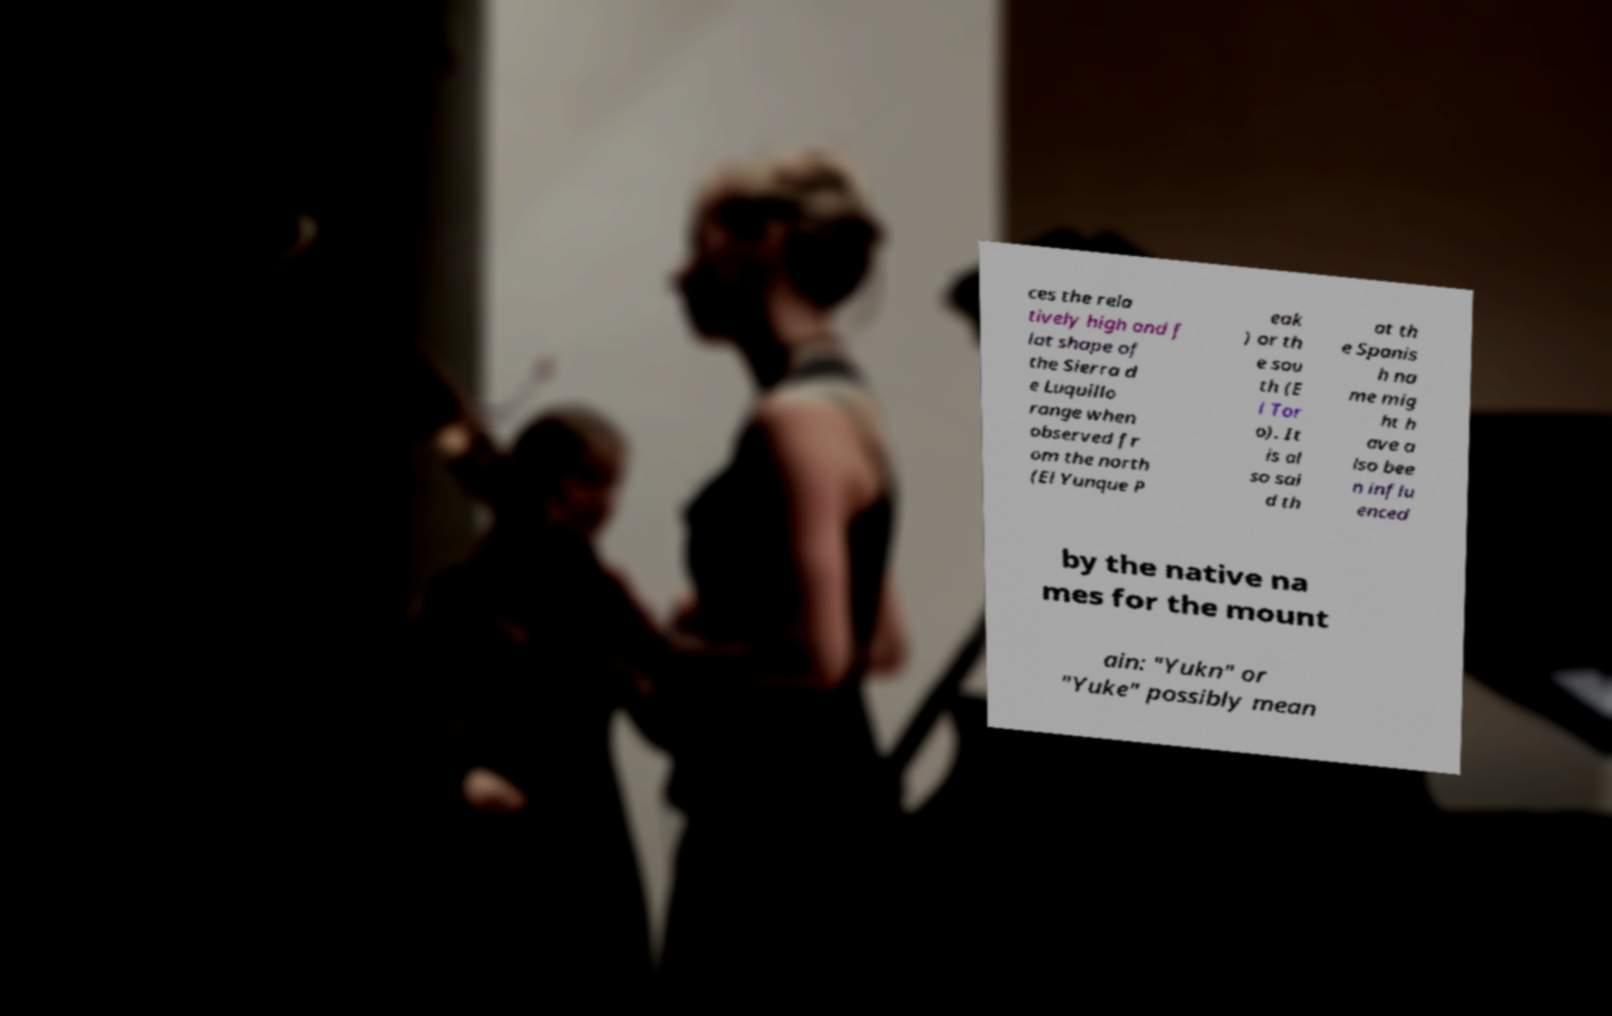Can you accurately transcribe the text from the provided image for me? ces the rela tively high and f lat shape of the Sierra d e Luquillo range when observed fr om the north (El Yunque P eak ) or th e sou th (E l Tor o). It is al so sai d th at th e Spanis h na me mig ht h ave a lso bee n influ enced by the native na mes for the mount ain: "Yukn" or "Yuke" possibly mean 